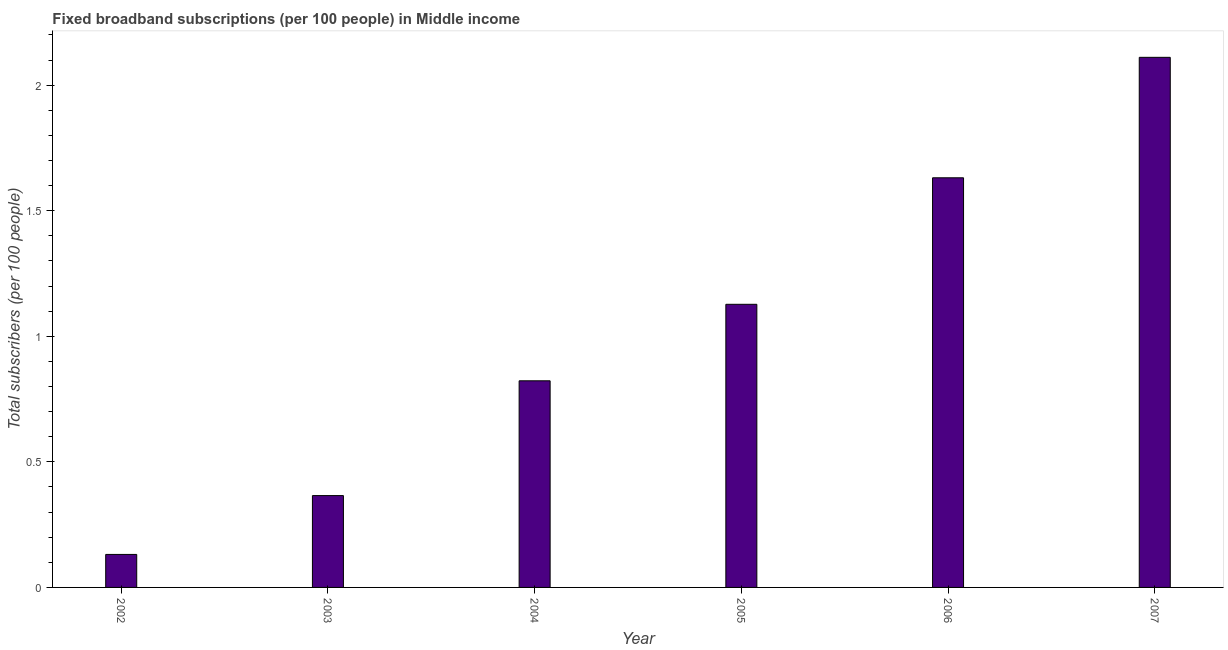Does the graph contain grids?
Provide a succinct answer. No. What is the title of the graph?
Your answer should be very brief. Fixed broadband subscriptions (per 100 people) in Middle income. What is the label or title of the Y-axis?
Provide a succinct answer. Total subscribers (per 100 people). What is the total number of fixed broadband subscriptions in 2006?
Make the answer very short. 1.63. Across all years, what is the maximum total number of fixed broadband subscriptions?
Provide a succinct answer. 2.11. Across all years, what is the minimum total number of fixed broadband subscriptions?
Provide a succinct answer. 0.13. In which year was the total number of fixed broadband subscriptions maximum?
Give a very brief answer. 2007. In which year was the total number of fixed broadband subscriptions minimum?
Ensure brevity in your answer.  2002. What is the sum of the total number of fixed broadband subscriptions?
Ensure brevity in your answer.  6.19. What is the difference between the total number of fixed broadband subscriptions in 2005 and 2006?
Your response must be concise. -0.5. What is the average total number of fixed broadband subscriptions per year?
Your response must be concise. 1.03. What is the median total number of fixed broadband subscriptions?
Provide a short and direct response. 0.97. Do a majority of the years between 2002 and 2007 (inclusive) have total number of fixed broadband subscriptions greater than 1.4 ?
Provide a succinct answer. No. What is the ratio of the total number of fixed broadband subscriptions in 2004 to that in 2006?
Provide a succinct answer. 0.5. Is the total number of fixed broadband subscriptions in 2005 less than that in 2007?
Your response must be concise. Yes. Is the difference between the total number of fixed broadband subscriptions in 2003 and 2005 greater than the difference between any two years?
Give a very brief answer. No. What is the difference between the highest and the second highest total number of fixed broadband subscriptions?
Make the answer very short. 0.48. Is the sum of the total number of fixed broadband subscriptions in 2002 and 2006 greater than the maximum total number of fixed broadband subscriptions across all years?
Ensure brevity in your answer.  No. What is the difference between the highest and the lowest total number of fixed broadband subscriptions?
Your answer should be very brief. 1.98. In how many years, is the total number of fixed broadband subscriptions greater than the average total number of fixed broadband subscriptions taken over all years?
Your answer should be very brief. 3. Are all the bars in the graph horizontal?
Give a very brief answer. No. Are the values on the major ticks of Y-axis written in scientific E-notation?
Keep it short and to the point. No. What is the Total subscribers (per 100 people) of 2002?
Provide a short and direct response. 0.13. What is the Total subscribers (per 100 people) in 2003?
Make the answer very short. 0.37. What is the Total subscribers (per 100 people) in 2004?
Your answer should be very brief. 0.82. What is the Total subscribers (per 100 people) of 2005?
Offer a very short reply. 1.13. What is the Total subscribers (per 100 people) of 2006?
Provide a short and direct response. 1.63. What is the Total subscribers (per 100 people) of 2007?
Ensure brevity in your answer.  2.11. What is the difference between the Total subscribers (per 100 people) in 2002 and 2003?
Your answer should be very brief. -0.23. What is the difference between the Total subscribers (per 100 people) in 2002 and 2004?
Your response must be concise. -0.69. What is the difference between the Total subscribers (per 100 people) in 2002 and 2005?
Offer a very short reply. -1. What is the difference between the Total subscribers (per 100 people) in 2002 and 2006?
Offer a terse response. -1.5. What is the difference between the Total subscribers (per 100 people) in 2002 and 2007?
Give a very brief answer. -1.98. What is the difference between the Total subscribers (per 100 people) in 2003 and 2004?
Keep it short and to the point. -0.46. What is the difference between the Total subscribers (per 100 people) in 2003 and 2005?
Offer a terse response. -0.76. What is the difference between the Total subscribers (per 100 people) in 2003 and 2006?
Your response must be concise. -1.27. What is the difference between the Total subscribers (per 100 people) in 2003 and 2007?
Provide a short and direct response. -1.74. What is the difference between the Total subscribers (per 100 people) in 2004 and 2005?
Provide a short and direct response. -0.3. What is the difference between the Total subscribers (per 100 people) in 2004 and 2006?
Your response must be concise. -0.81. What is the difference between the Total subscribers (per 100 people) in 2004 and 2007?
Your response must be concise. -1.29. What is the difference between the Total subscribers (per 100 people) in 2005 and 2006?
Make the answer very short. -0.5. What is the difference between the Total subscribers (per 100 people) in 2005 and 2007?
Your response must be concise. -0.98. What is the difference between the Total subscribers (per 100 people) in 2006 and 2007?
Keep it short and to the point. -0.48. What is the ratio of the Total subscribers (per 100 people) in 2002 to that in 2003?
Provide a short and direct response. 0.36. What is the ratio of the Total subscribers (per 100 people) in 2002 to that in 2004?
Keep it short and to the point. 0.16. What is the ratio of the Total subscribers (per 100 people) in 2002 to that in 2005?
Your response must be concise. 0.12. What is the ratio of the Total subscribers (per 100 people) in 2002 to that in 2006?
Offer a terse response. 0.08. What is the ratio of the Total subscribers (per 100 people) in 2002 to that in 2007?
Give a very brief answer. 0.06. What is the ratio of the Total subscribers (per 100 people) in 2003 to that in 2004?
Your answer should be compact. 0.45. What is the ratio of the Total subscribers (per 100 people) in 2003 to that in 2005?
Provide a short and direct response. 0.32. What is the ratio of the Total subscribers (per 100 people) in 2003 to that in 2006?
Provide a short and direct response. 0.22. What is the ratio of the Total subscribers (per 100 people) in 2003 to that in 2007?
Offer a very short reply. 0.17. What is the ratio of the Total subscribers (per 100 people) in 2004 to that in 2005?
Offer a terse response. 0.73. What is the ratio of the Total subscribers (per 100 people) in 2004 to that in 2006?
Your response must be concise. 0.5. What is the ratio of the Total subscribers (per 100 people) in 2004 to that in 2007?
Provide a short and direct response. 0.39. What is the ratio of the Total subscribers (per 100 people) in 2005 to that in 2006?
Provide a succinct answer. 0.69. What is the ratio of the Total subscribers (per 100 people) in 2005 to that in 2007?
Provide a succinct answer. 0.53. What is the ratio of the Total subscribers (per 100 people) in 2006 to that in 2007?
Offer a terse response. 0.77. 